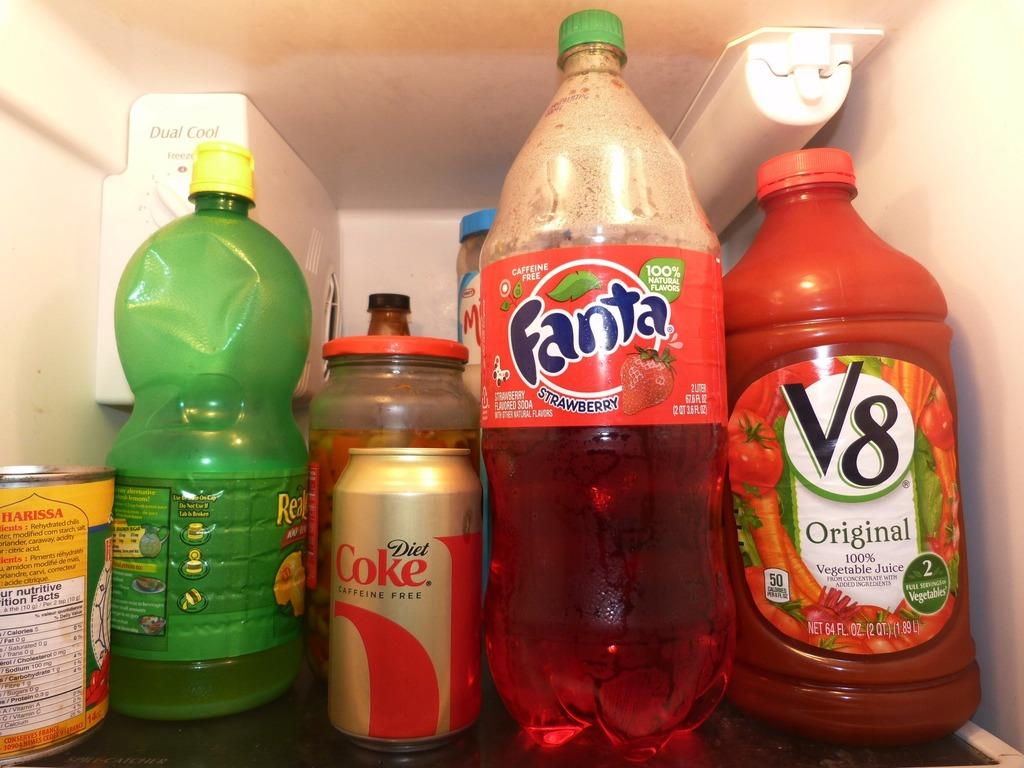What type of containers are visible in the image? There are bottles and a tin in the image. Where are the bottles and tin located? The bottles and tin are inside a refrigerator. What type of tree can be seen growing inside the refrigerator in the image? There is no tree present in the image; the bottles and tin are inside a refrigerator. 